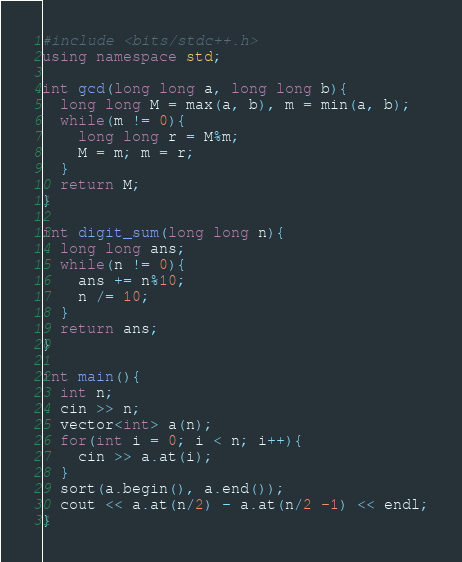<code> <loc_0><loc_0><loc_500><loc_500><_C++_>#include <bits/stdc++.h>
using namespace std;

int gcd(long long a, long long b){
  long long M = max(a, b), m = min(a, b);
  while(m != 0){
  	long long r = M%m;
    M = m; m = r;
  }
  return M;
}

int digit_sum(long long n){
  long long ans;
  while(n != 0){
  	ans += n%10;
  	n /= 10;
  }
  return ans;
}

int main(){
  int n;
  cin >> n;
  vector<int> a(n);
  for(int i = 0; i < n; i++){
  	cin >> a.at(i);
  }
  sort(a.begin(), a.end());
  cout << a.at(n/2) - a.at(n/2 -1) << endl;
}
</code> 